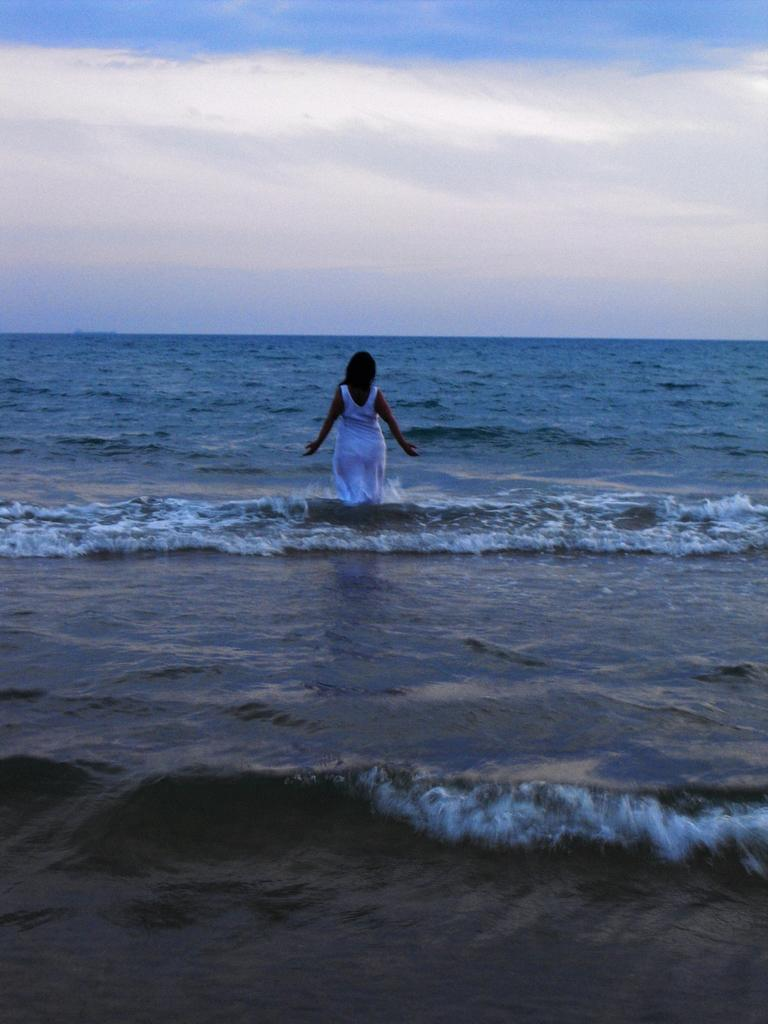Who is present in the image? There is a lady in the image. What is the lady doing in the image? The lady is standing in the ocean. What can be seen in the background of the image? The sky is visible in the image. What type of yak can be seen in the image? There is no yak present in the image; it features a lady standing in the ocean. How many fingers does the lady have in the image? The number of fingers the lady has cannot be determined from the image alone, as hands are not clearly visible. 